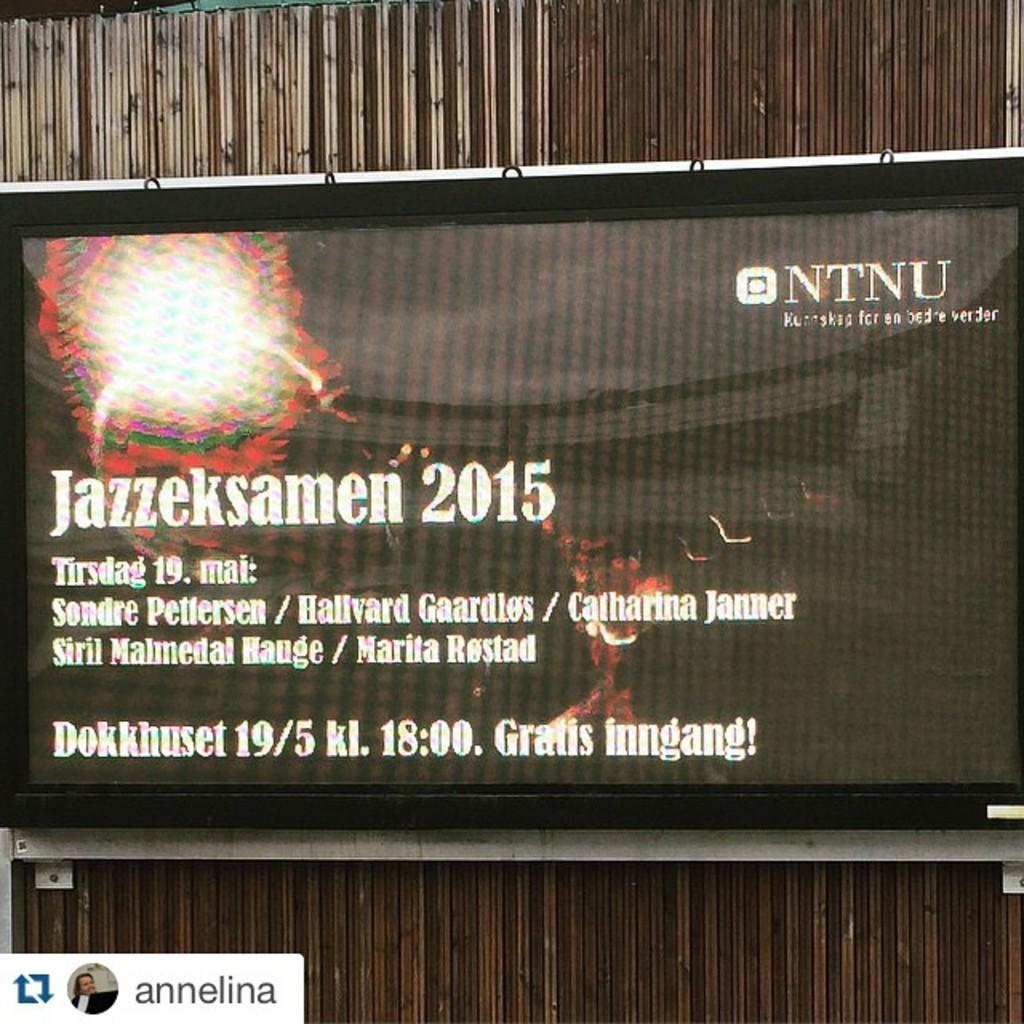<image>
Relay a brief, clear account of the picture shown. A screen displays NTNU in the upper right corner. 